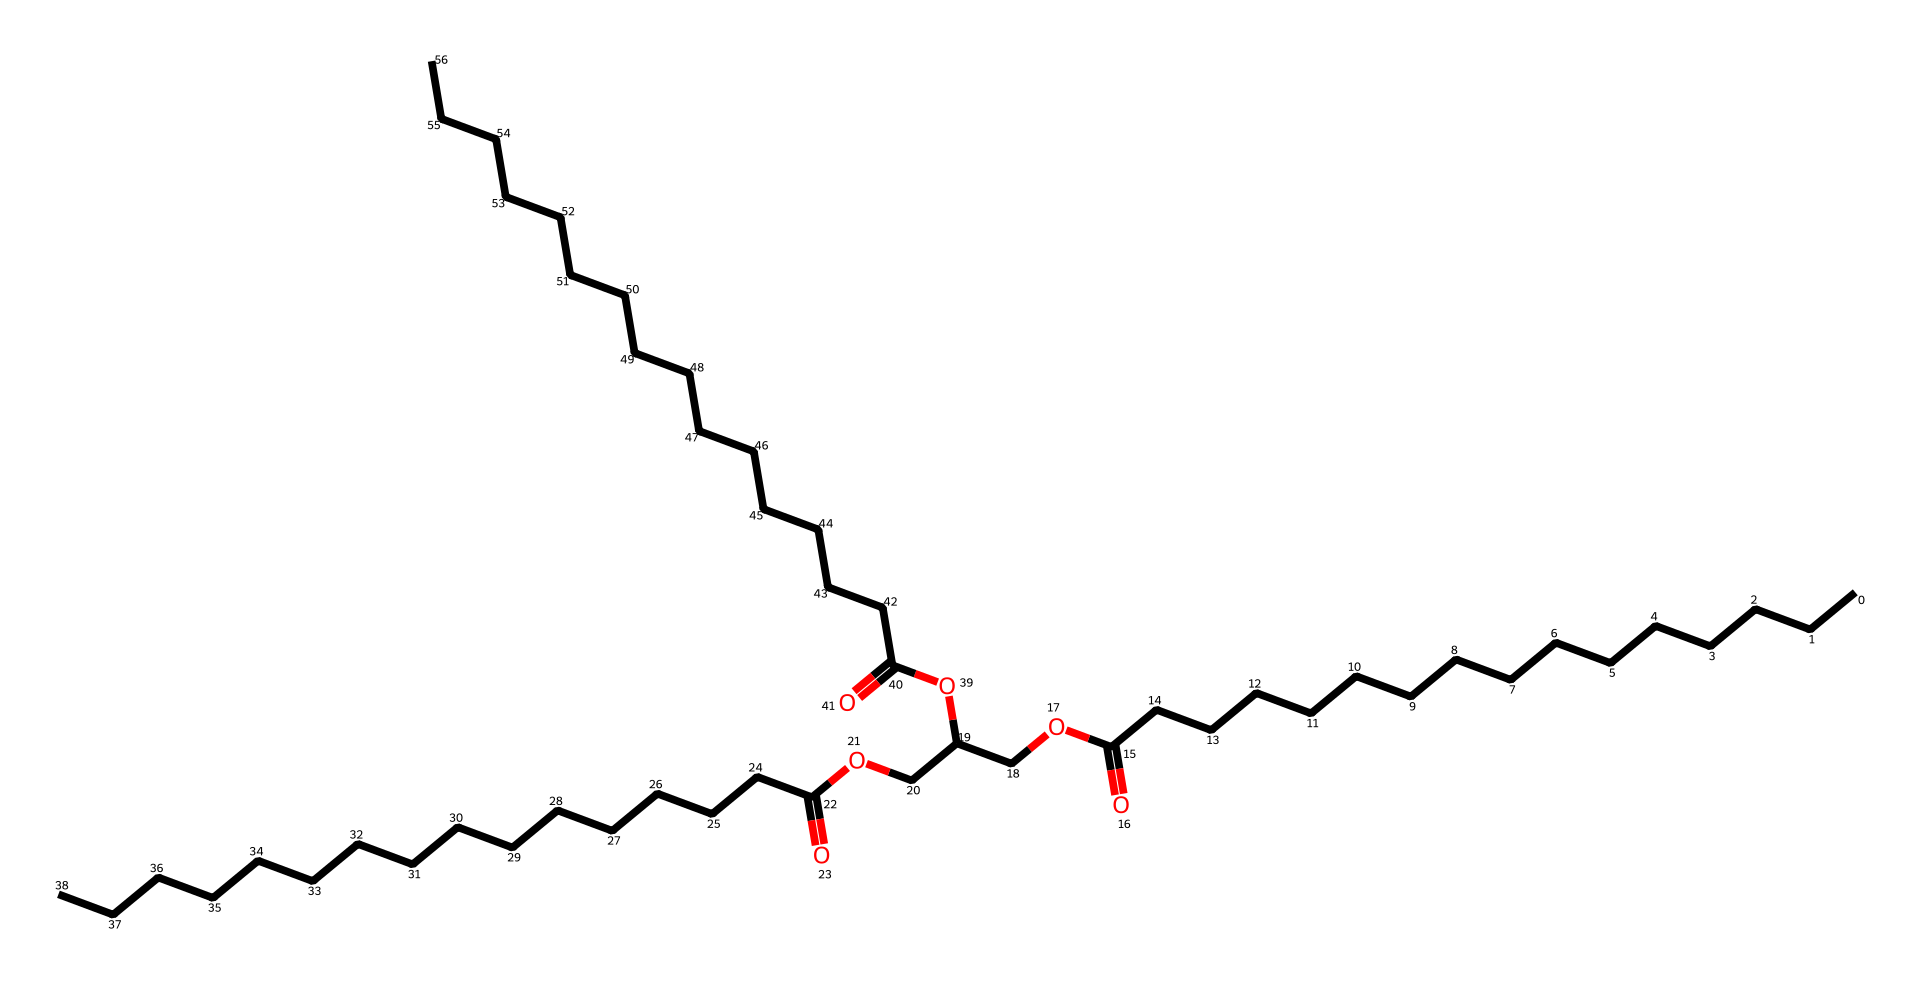What type of lipid is represented by this SMILES structure? The structure given represents a triglyceride, which is a glycerol molecule bonded to three fatty acid chains. This is characteristic of lipids known for energy storage and insulation.
Answer: triglyceride How many carbon atoms are in the longest fatty acid chain? By analyzing the structure, we can count the carbon atoms in the longest chain, which consists of 15 carbon atoms in the longest fatty acid.
Answer: fifteen How many ester bonds are present in this chemical structure? In the given SMILES representation, there are three ester bonds connecting the glycerol backbone to the fatty acids, as seen by the presence of the -O- groups after the carbonyls.
Answer: three What is the functional group responsible for the lipid's energy storage properties? The ester functional group is crucial in triglycerides, allowing them to store energy efficiently. This is evident in the structure as the COOR segments (where R is the fatty acid chain).
Answer: ester What characteristic of this triglyceride contributes to its solid state at room temperature? The presence of long saturated fatty acid chains in the structure (exceeding a certain length) leads to a higher melting point, thus contributing to the solid state of the triglyceride at room temperature.
Answer: saturated fatty acids Which part of the structure indicates that it exists as a triglyceride? The central glycerol molecule is directly bonded to three distinct fatty acid chains as indicated by the three ester linkages in the structure. This connectivity indicates its triglyceride form.
Answer: glycerol 